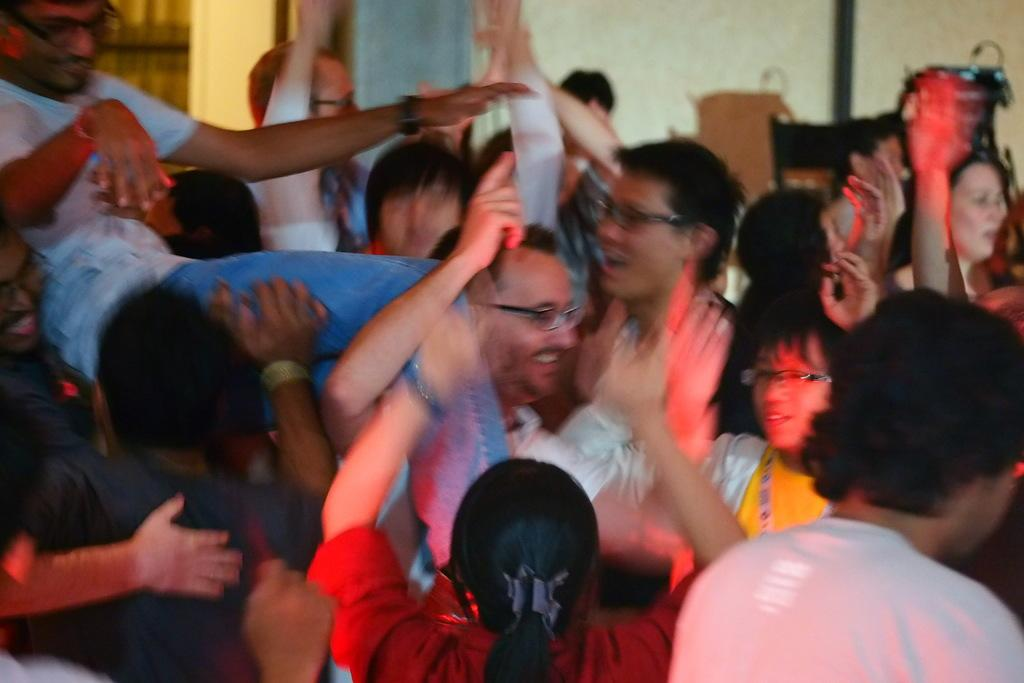What is happening in the image? There are people standing in the image. Where are the people standing? The people are standing on the floor. What can be seen in the background of the image? There is a wall visible in the background of the image. What type of doctor is treating the people in the image? There is no doctor present in the image; it only shows people standing on the floor. 